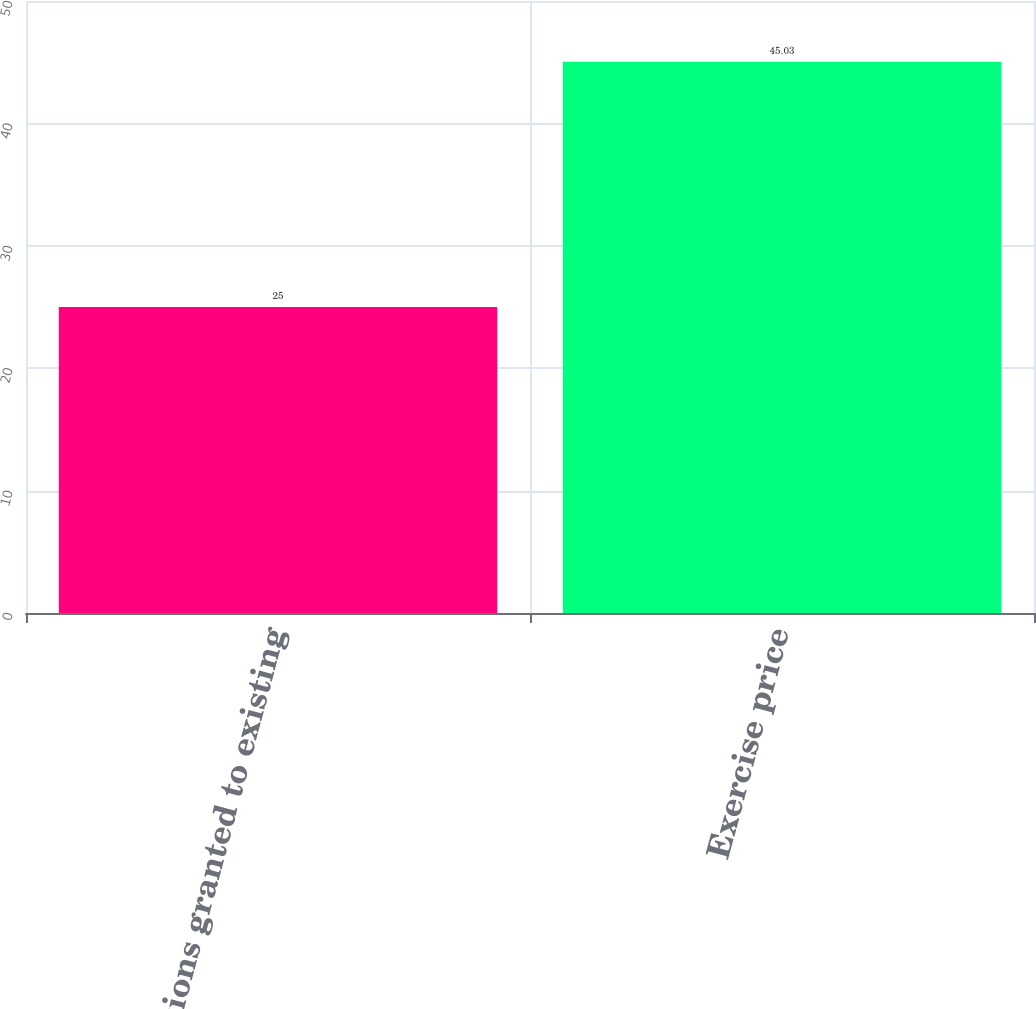<chart> <loc_0><loc_0><loc_500><loc_500><bar_chart><fcel>Options granted to existing<fcel>Exercise price<nl><fcel>25<fcel>45.03<nl></chart> 